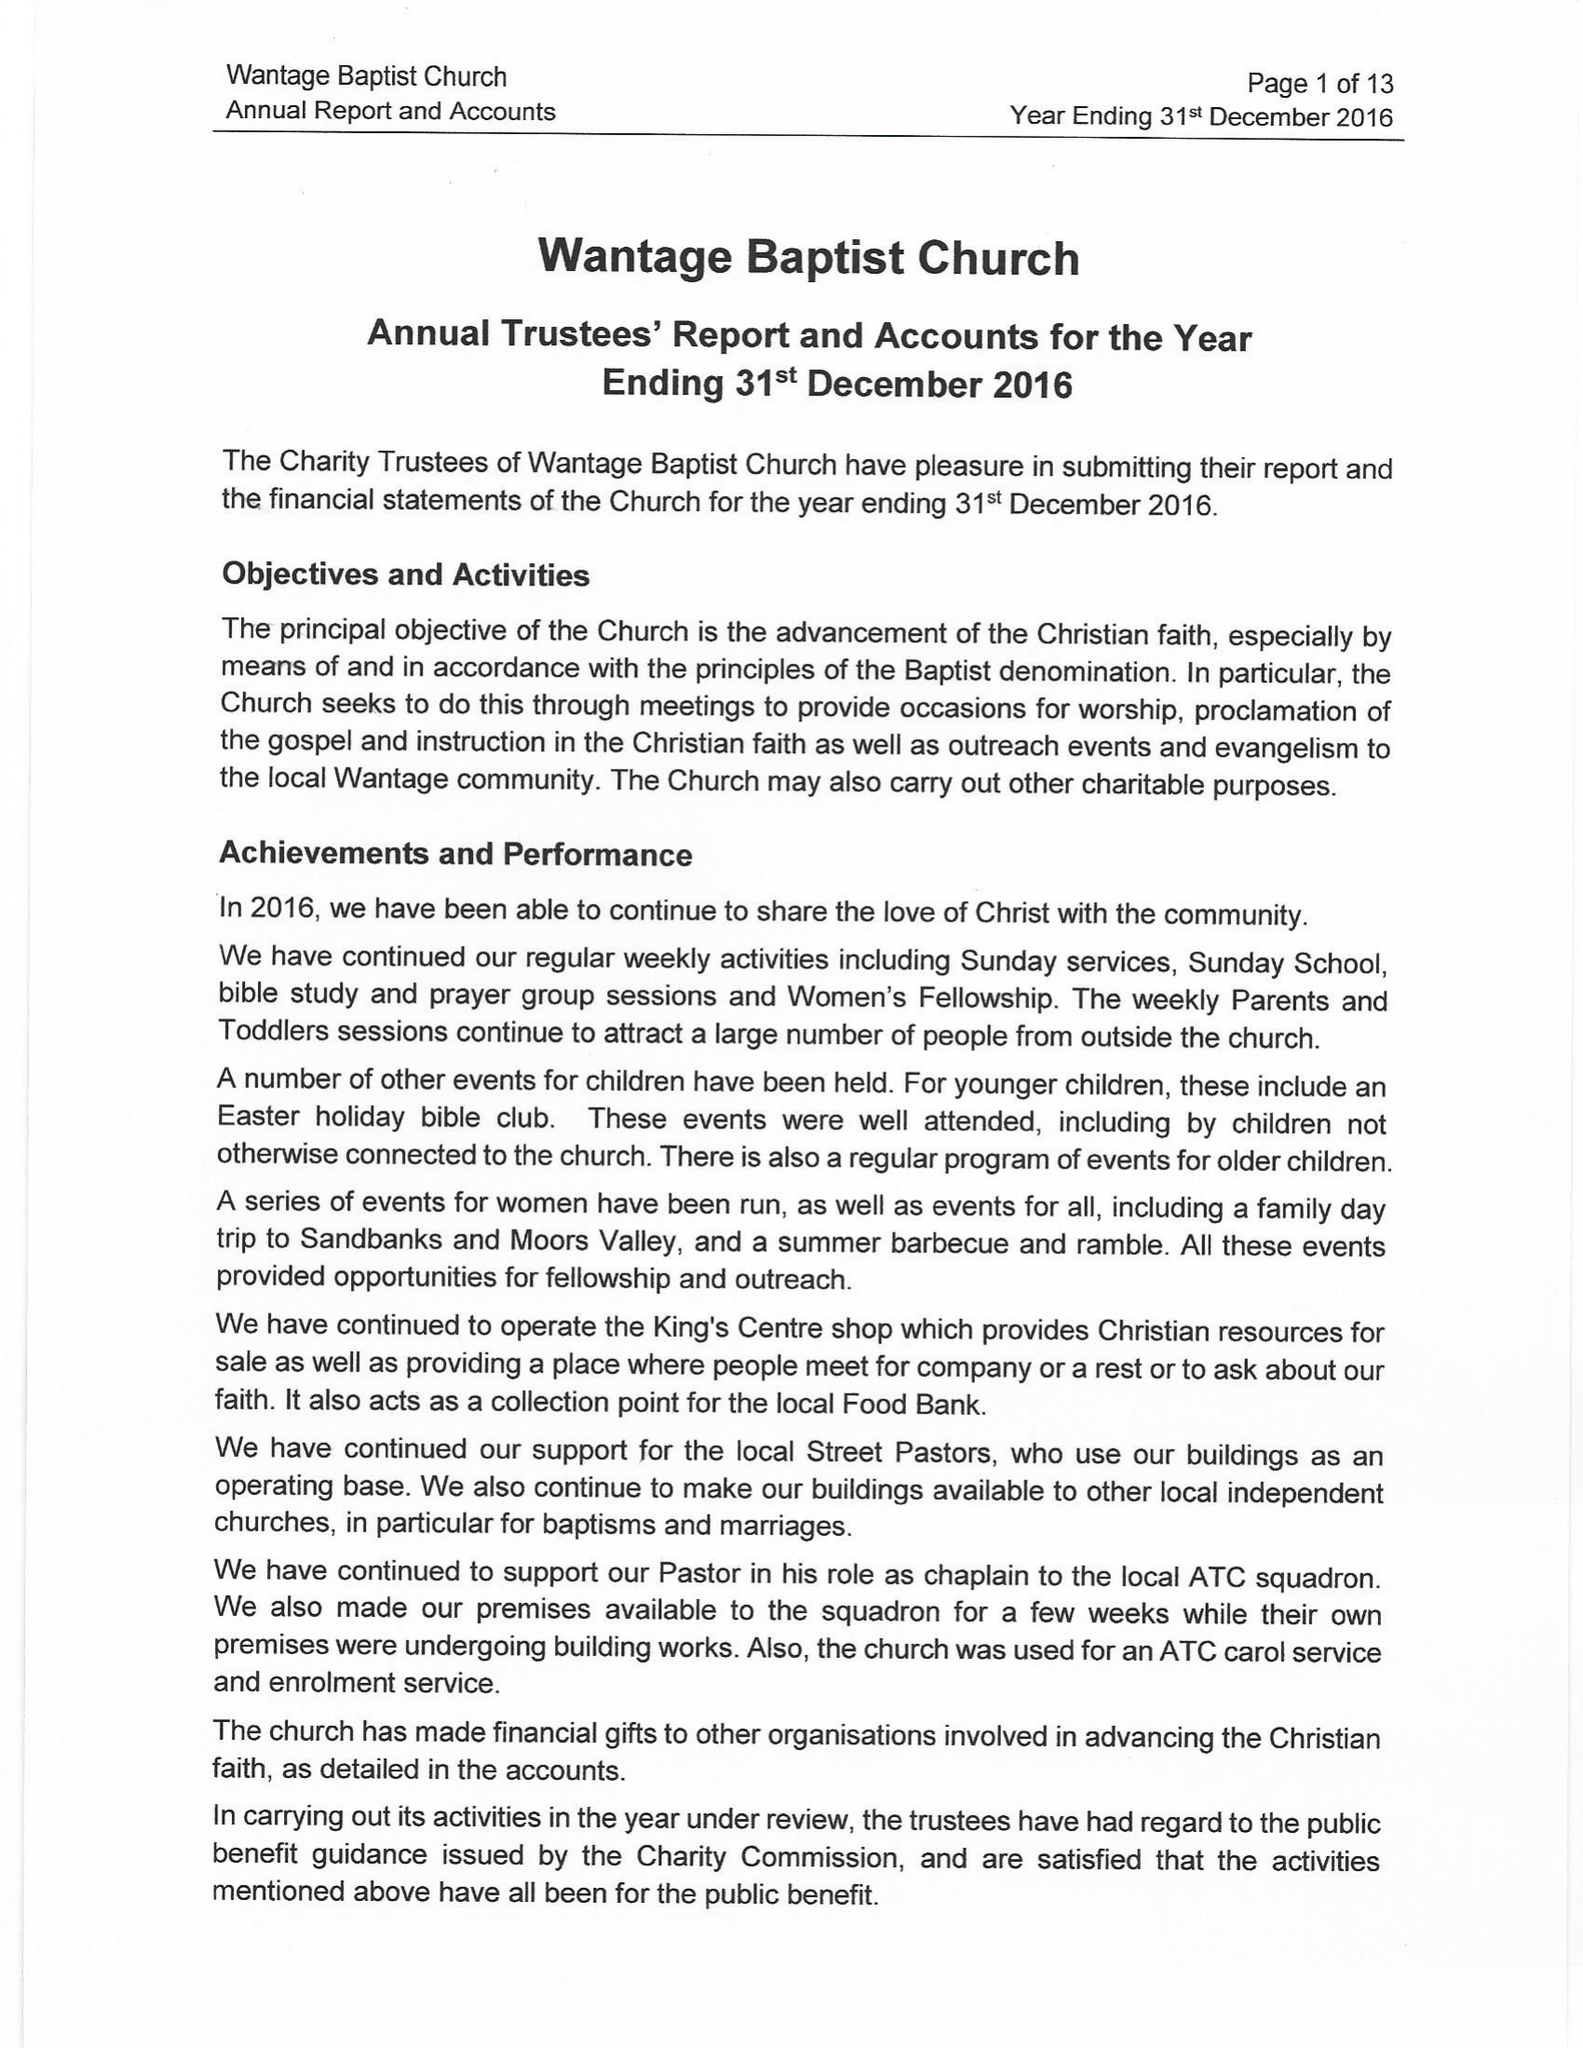What is the value for the charity_name?
Answer the question using a single word or phrase. Wantage Baptist Church 